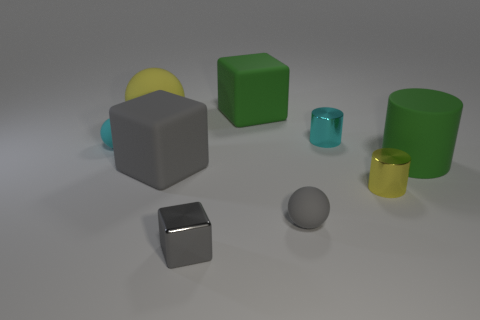Subtract all tiny cylinders. How many cylinders are left? 1 Subtract all purple balls. How many gray blocks are left? 2 Subtract 1 balls. How many balls are left? 2 Subtract all red balls. Subtract all cyan cylinders. How many balls are left? 3 Add 1 large matte things. How many objects exist? 10 Add 6 tiny blocks. How many tiny blocks are left? 7 Add 3 shiny cylinders. How many shiny cylinders exist? 5 Subtract 0 blue blocks. How many objects are left? 9 Subtract all blocks. How many objects are left? 6 Subtract all cyan metal cylinders. Subtract all gray metallic things. How many objects are left? 7 